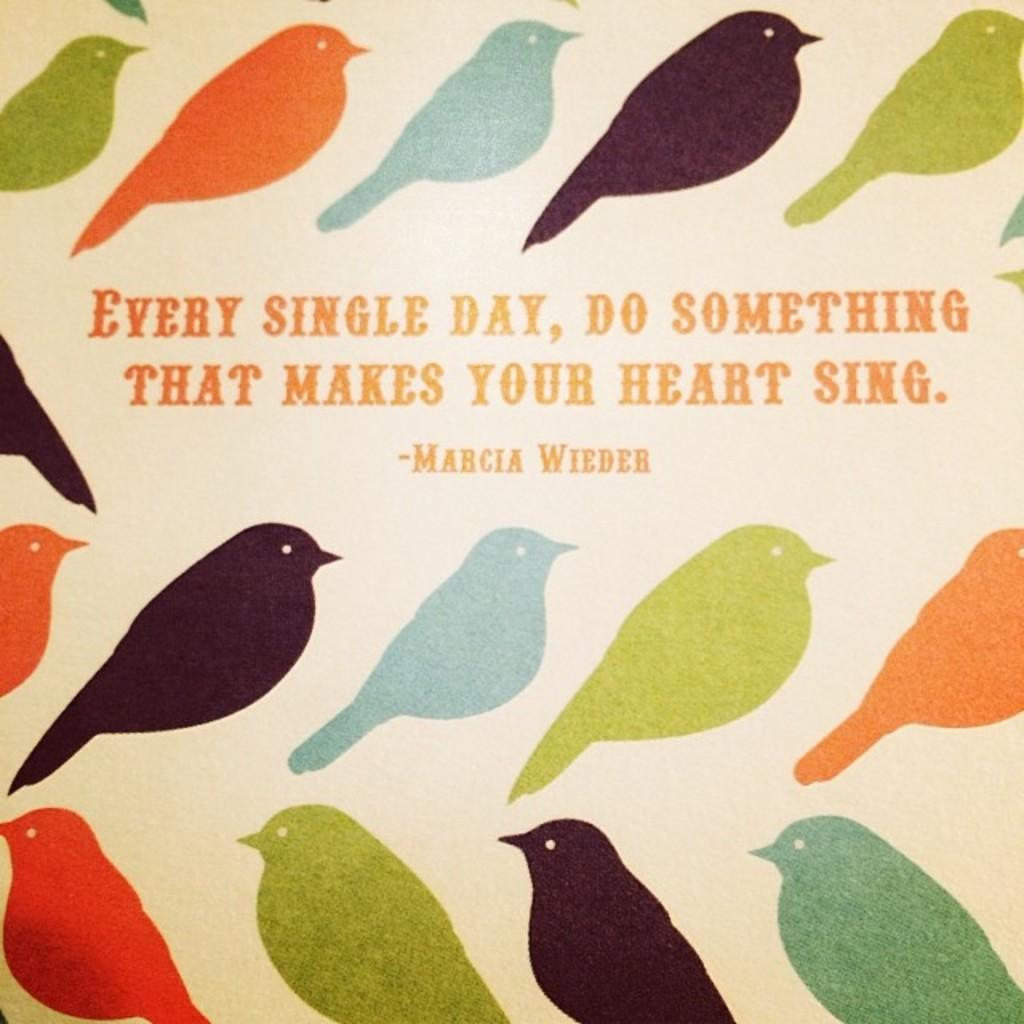What type of animals can be seen in the image? There are depictions of birds in the image. What else is present in the middle of the image besides the birds? There is some text in the middle of the image. What type of elbow can be seen in the image? There is no elbow present in the image. What is the pen used for in the image? There is no pen present in the image. 